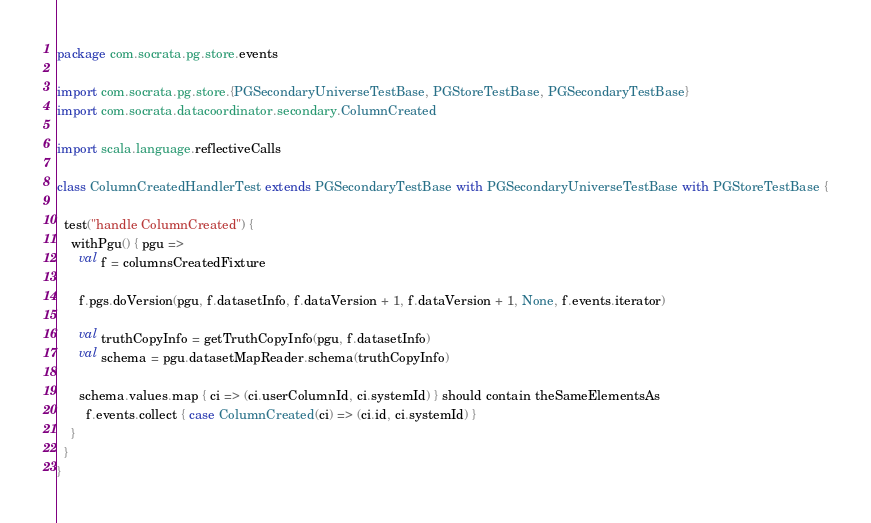<code> <loc_0><loc_0><loc_500><loc_500><_Scala_>package com.socrata.pg.store.events

import com.socrata.pg.store.{PGSecondaryUniverseTestBase, PGStoreTestBase, PGSecondaryTestBase}
import com.socrata.datacoordinator.secondary.ColumnCreated

import scala.language.reflectiveCalls

class ColumnCreatedHandlerTest extends PGSecondaryTestBase with PGSecondaryUniverseTestBase with PGStoreTestBase {

  test("handle ColumnCreated") {
    withPgu() { pgu =>
      val f = columnsCreatedFixture

      f.pgs.doVersion(pgu, f.datasetInfo, f.dataVersion + 1, f.dataVersion + 1, None, f.events.iterator)

      val truthCopyInfo = getTruthCopyInfo(pgu, f.datasetInfo)
      val schema = pgu.datasetMapReader.schema(truthCopyInfo)

      schema.values.map { ci => (ci.userColumnId, ci.systemId) } should contain theSameElementsAs
        f.events.collect { case ColumnCreated(ci) => (ci.id, ci.systemId) }
    }
  }
}
</code> 